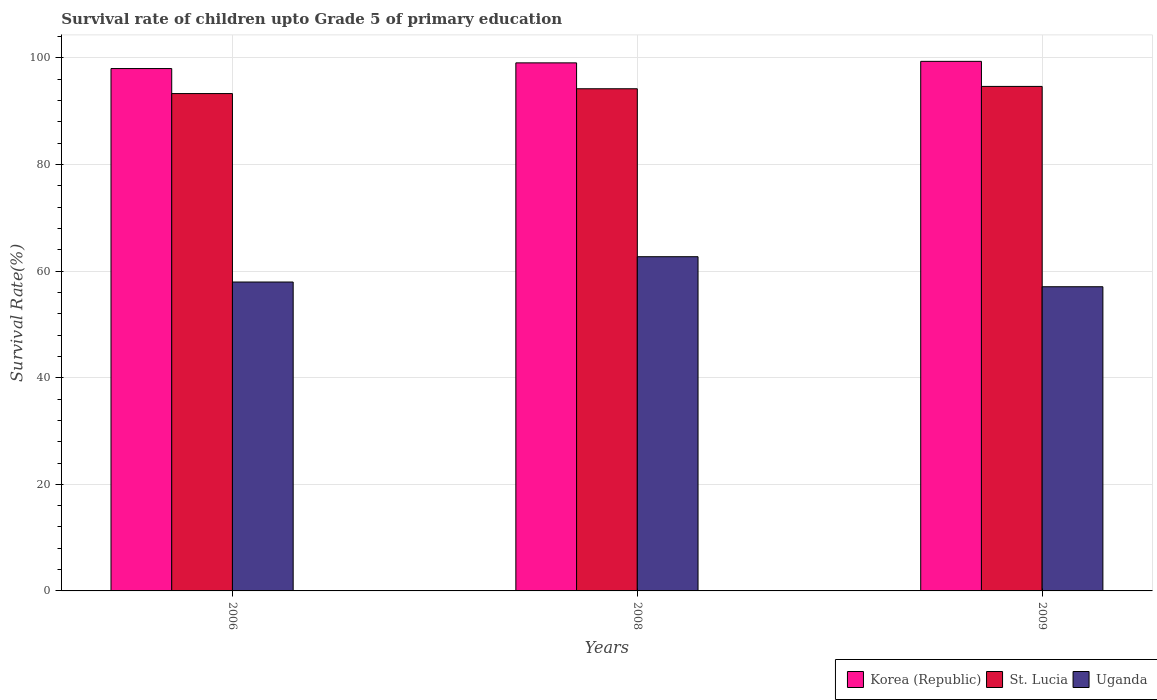Are the number of bars on each tick of the X-axis equal?
Give a very brief answer. Yes. How many bars are there on the 3rd tick from the right?
Your answer should be very brief. 3. What is the label of the 2nd group of bars from the left?
Your answer should be very brief. 2008. In how many cases, is the number of bars for a given year not equal to the number of legend labels?
Your response must be concise. 0. What is the survival rate of children in St. Lucia in 2009?
Make the answer very short. 94.67. Across all years, what is the maximum survival rate of children in Uganda?
Make the answer very short. 62.71. Across all years, what is the minimum survival rate of children in Uganda?
Your response must be concise. 57.08. What is the total survival rate of children in St. Lucia in the graph?
Provide a short and direct response. 282.22. What is the difference between the survival rate of children in Uganda in 2008 and that in 2009?
Offer a very short reply. 5.63. What is the difference between the survival rate of children in Uganda in 2008 and the survival rate of children in St. Lucia in 2006?
Offer a terse response. -30.61. What is the average survival rate of children in Korea (Republic) per year?
Give a very brief answer. 98.82. In the year 2006, what is the difference between the survival rate of children in St. Lucia and survival rate of children in Korea (Republic)?
Your response must be concise. -4.7. What is the ratio of the survival rate of children in Uganda in 2006 to that in 2009?
Give a very brief answer. 1.02. What is the difference between the highest and the second highest survival rate of children in Korea (Republic)?
Provide a short and direct response. 0.28. What is the difference between the highest and the lowest survival rate of children in St. Lucia?
Offer a terse response. 1.34. In how many years, is the survival rate of children in St. Lucia greater than the average survival rate of children in St. Lucia taken over all years?
Provide a succinct answer. 2. What does the 2nd bar from the left in 2009 represents?
Make the answer very short. St. Lucia. Are all the bars in the graph horizontal?
Your answer should be very brief. No. What is the difference between two consecutive major ticks on the Y-axis?
Make the answer very short. 20. Does the graph contain any zero values?
Offer a terse response. No. How many legend labels are there?
Make the answer very short. 3. What is the title of the graph?
Your answer should be very brief. Survival rate of children upto Grade 5 of primary education. What is the label or title of the Y-axis?
Your answer should be very brief. Survival Rate(%). What is the Survival Rate(%) of Korea (Republic) in 2006?
Keep it short and to the point. 98.02. What is the Survival Rate(%) in St. Lucia in 2006?
Provide a succinct answer. 93.32. What is the Survival Rate(%) of Uganda in 2006?
Keep it short and to the point. 57.96. What is the Survival Rate(%) in Korea (Republic) in 2008?
Your answer should be compact. 99.09. What is the Survival Rate(%) of St. Lucia in 2008?
Offer a very short reply. 94.23. What is the Survival Rate(%) in Uganda in 2008?
Offer a terse response. 62.71. What is the Survival Rate(%) in Korea (Republic) in 2009?
Give a very brief answer. 99.37. What is the Survival Rate(%) of St. Lucia in 2009?
Offer a terse response. 94.67. What is the Survival Rate(%) of Uganda in 2009?
Your answer should be very brief. 57.08. Across all years, what is the maximum Survival Rate(%) of Korea (Republic)?
Your answer should be compact. 99.37. Across all years, what is the maximum Survival Rate(%) of St. Lucia?
Provide a short and direct response. 94.67. Across all years, what is the maximum Survival Rate(%) in Uganda?
Provide a succinct answer. 62.71. Across all years, what is the minimum Survival Rate(%) in Korea (Republic)?
Offer a very short reply. 98.02. Across all years, what is the minimum Survival Rate(%) in St. Lucia?
Your answer should be compact. 93.32. Across all years, what is the minimum Survival Rate(%) in Uganda?
Give a very brief answer. 57.08. What is the total Survival Rate(%) of Korea (Republic) in the graph?
Your answer should be compact. 296.47. What is the total Survival Rate(%) of St. Lucia in the graph?
Ensure brevity in your answer.  282.22. What is the total Survival Rate(%) of Uganda in the graph?
Provide a short and direct response. 177.75. What is the difference between the Survival Rate(%) in Korea (Republic) in 2006 and that in 2008?
Your answer should be compact. -1.07. What is the difference between the Survival Rate(%) of St. Lucia in 2006 and that in 2008?
Provide a short and direct response. -0.9. What is the difference between the Survival Rate(%) of Uganda in 2006 and that in 2008?
Offer a terse response. -4.75. What is the difference between the Survival Rate(%) of Korea (Republic) in 2006 and that in 2009?
Provide a succinct answer. -1.35. What is the difference between the Survival Rate(%) of St. Lucia in 2006 and that in 2009?
Keep it short and to the point. -1.34. What is the difference between the Survival Rate(%) in Uganda in 2006 and that in 2009?
Offer a very short reply. 0.88. What is the difference between the Survival Rate(%) of Korea (Republic) in 2008 and that in 2009?
Provide a succinct answer. -0.28. What is the difference between the Survival Rate(%) of St. Lucia in 2008 and that in 2009?
Give a very brief answer. -0.44. What is the difference between the Survival Rate(%) of Uganda in 2008 and that in 2009?
Your answer should be compact. 5.63. What is the difference between the Survival Rate(%) in Korea (Republic) in 2006 and the Survival Rate(%) in St. Lucia in 2008?
Give a very brief answer. 3.79. What is the difference between the Survival Rate(%) of Korea (Republic) in 2006 and the Survival Rate(%) of Uganda in 2008?
Ensure brevity in your answer.  35.31. What is the difference between the Survival Rate(%) of St. Lucia in 2006 and the Survival Rate(%) of Uganda in 2008?
Offer a terse response. 30.61. What is the difference between the Survival Rate(%) in Korea (Republic) in 2006 and the Survival Rate(%) in St. Lucia in 2009?
Provide a short and direct response. 3.35. What is the difference between the Survival Rate(%) of Korea (Republic) in 2006 and the Survival Rate(%) of Uganda in 2009?
Your answer should be very brief. 40.94. What is the difference between the Survival Rate(%) in St. Lucia in 2006 and the Survival Rate(%) in Uganda in 2009?
Your answer should be very brief. 36.25. What is the difference between the Survival Rate(%) in Korea (Republic) in 2008 and the Survival Rate(%) in St. Lucia in 2009?
Your answer should be compact. 4.42. What is the difference between the Survival Rate(%) of Korea (Republic) in 2008 and the Survival Rate(%) of Uganda in 2009?
Give a very brief answer. 42.01. What is the difference between the Survival Rate(%) of St. Lucia in 2008 and the Survival Rate(%) of Uganda in 2009?
Give a very brief answer. 37.15. What is the average Survival Rate(%) of Korea (Republic) per year?
Your answer should be very brief. 98.82. What is the average Survival Rate(%) in St. Lucia per year?
Offer a terse response. 94.07. What is the average Survival Rate(%) in Uganda per year?
Make the answer very short. 59.25. In the year 2006, what is the difference between the Survival Rate(%) in Korea (Republic) and Survival Rate(%) in St. Lucia?
Give a very brief answer. 4.7. In the year 2006, what is the difference between the Survival Rate(%) in Korea (Republic) and Survival Rate(%) in Uganda?
Your answer should be very brief. 40.06. In the year 2006, what is the difference between the Survival Rate(%) in St. Lucia and Survival Rate(%) in Uganda?
Provide a short and direct response. 35.36. In the year 2008, what is the difference between the Survival Rate(%) in Korea (Republic) and Survival Rate(%) in St. Lucia?
Offer a terse response. 4.86. In the year 2008, what is the difference between the Survival Rate(%) in Korea (Republic) and Survival Rate(%) in Uganda?
Your answer should be very brief. 36.38. In the year 2008, what is the difference between the Survival Rate(%) of St. Lucia and Survival Rate(%) of Uganda?
Keep it short and to the point. 31.52. In the year 2009, what is the difference between the Survival Rate(%) of Korea (Republic) and Survival Rate(%) of St. Lucia?
Your response must be concise. 4.7. In the year 2009, what is the difference between the Survival Rate(%) of Korea (Republic) and Survival Rate(%) of Uganda?
Make the answer very short. 42.29. In the year 2009, what is the difference between the Survival Rate(%) in St. Lucia and Survival Rate(%) in Uganda?
Ensure brevity in your answer.  37.59. What is the ratio of the Survival Rate(%) in Uganda in 2006 to that in 2008?
Keep it short and to the point. 0.92. What is the ratio of the Survival Rate(%) of Korea (Republic) in 2006 to that in 2009?
Provide a succinct answer. 0.99. What is the ratio of the Survival Rate(%) of St. Lucia in 2006 to that in 2009?
Offer a very short reply. 0.99. What is the ratio of the Survival Rate(%) in Uganda in 2006 to that in 2009?
Your answer should be compact. 1.02. What is the ratio of the Survival Rate(%) in Korea (Republic) in 2008 to that in 2009?
Your response must be concise. 1. What is the ratio of the Survival Rate(%) of St. Lucia in 2008 to that in 2009?
Keep it short and to the point. 1. What is the ratio of the Survival Rate(%) in Uganda in 2008 to that in 2009?
Ensure brevity in your answer.  1.1. What is the difference between the highest and the second highest Survival Rate(%) in Korea (Republic)?
Ensure brevity in your answer.  0.28. What is the difference between the highest and the second highest Survival Rate(%) in St. Lucia?
Ensure brevity in your answer.  0.44. What is the difference between the highest and the second highest Survival Rate(%) in Uganda?
Keep it short and to the point. 4.75. What is the difference between the highest and the lowest Survival Rate(%) of Korea (Republic)?
Your answer should be very brief. 1.35. What is the difference between the highest and the lowest Survival Rate(%) in St. Lucia?
Give a very brief answer. 1.34. What is the difference between the highest and the lowest Survival Rate(%) in Uganda?
Your answer should be very brief. 5.63. 